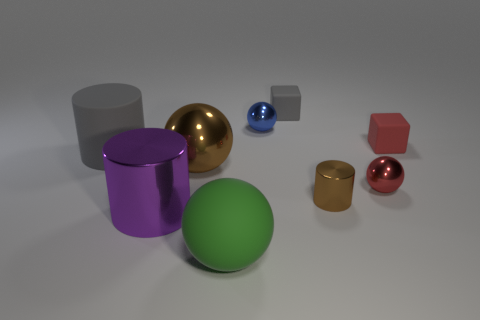Add 1 small green shiny spheres. How many objects exist? 10 Subtract all cylinders. How many objects are left? 6 Add 8 brown metallic objects. How many brown metallic objects are left? 10 Add 1 brown balls. How many brown balls exist? 2 Subtract 0 red cylinders. How many objects are left? 9 Subtract all red metal objects. Subtract all large purple objects. How many objects are left? 7 